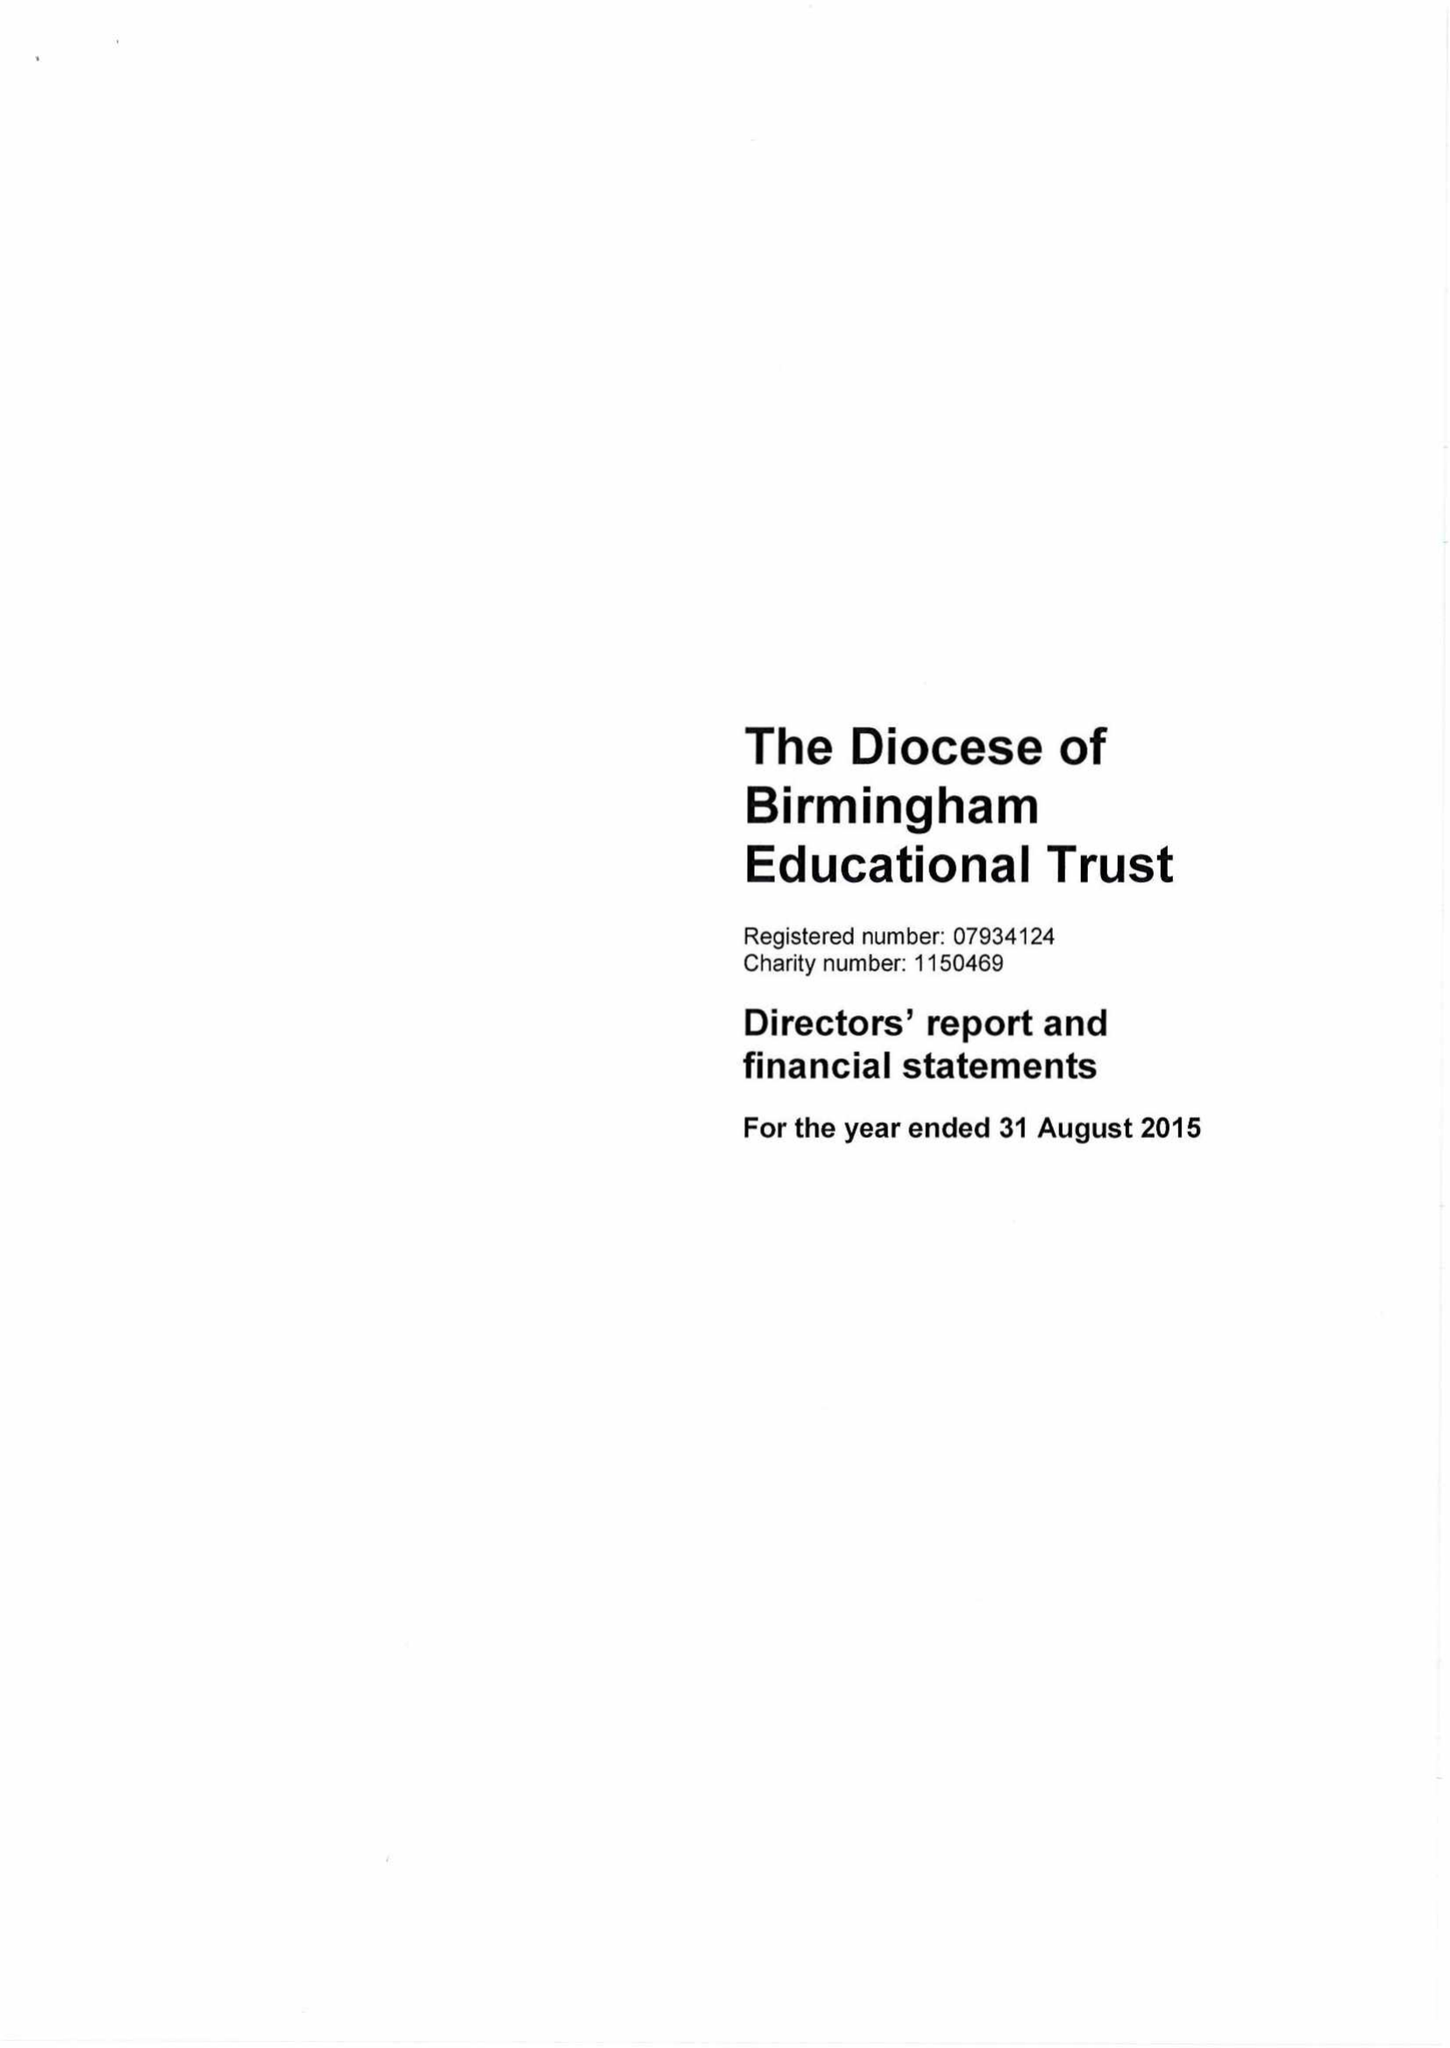What is the value for the charity_number?
Answer the question using a single word or phrase. 1150469 